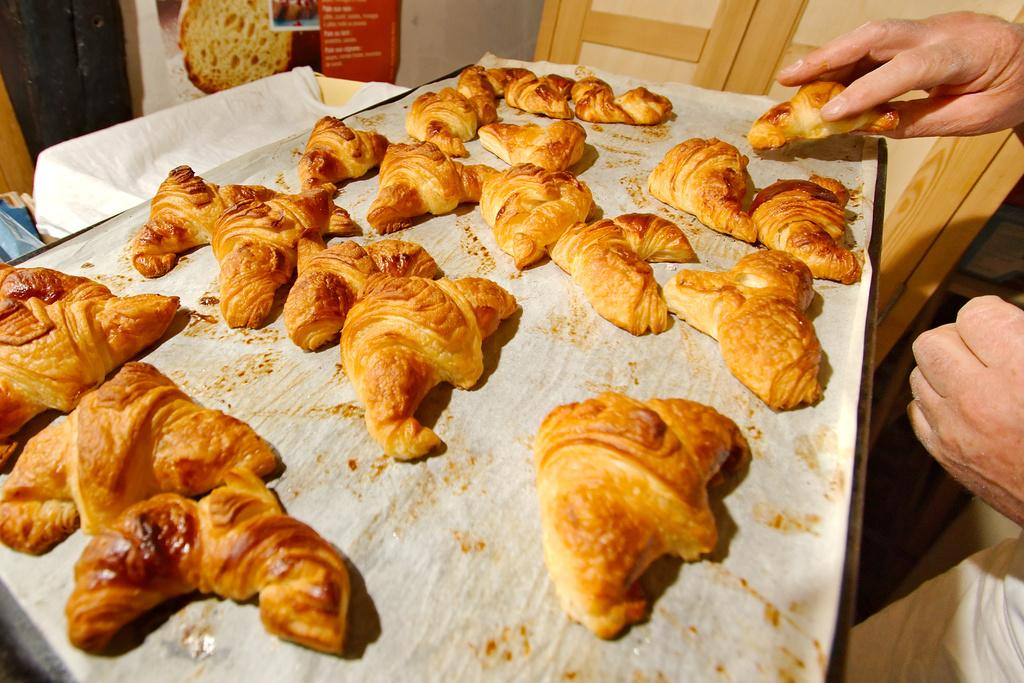What is placed on the tray in the image? There is food placed on a tray in the image. Can you describe the person on the right side of the image? There is a person on the right side of the image, but their appearance or actions are not specified. What can be seen in the background of the image? There is a poster and a wall in the background of the image. What type of animal is the governor visiting at the zoo in the image? There is no governor, zoo, or animal present in the image. 